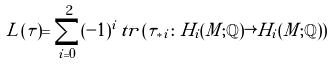Convert formula to latex. <formula><loc_0><loc_0><loc_500><loc_500>L ( \tau ) = \sum _ { i = 0 } ^ { 2 } ( - 1 ) ^ { i } \, t r \, ( \tau _ { * i } \colon H _ { i } ( M ; \mathbb { Q } ) \rightarrow H _ { i } ( M ; \mathbb { Q } ) )</formula> 